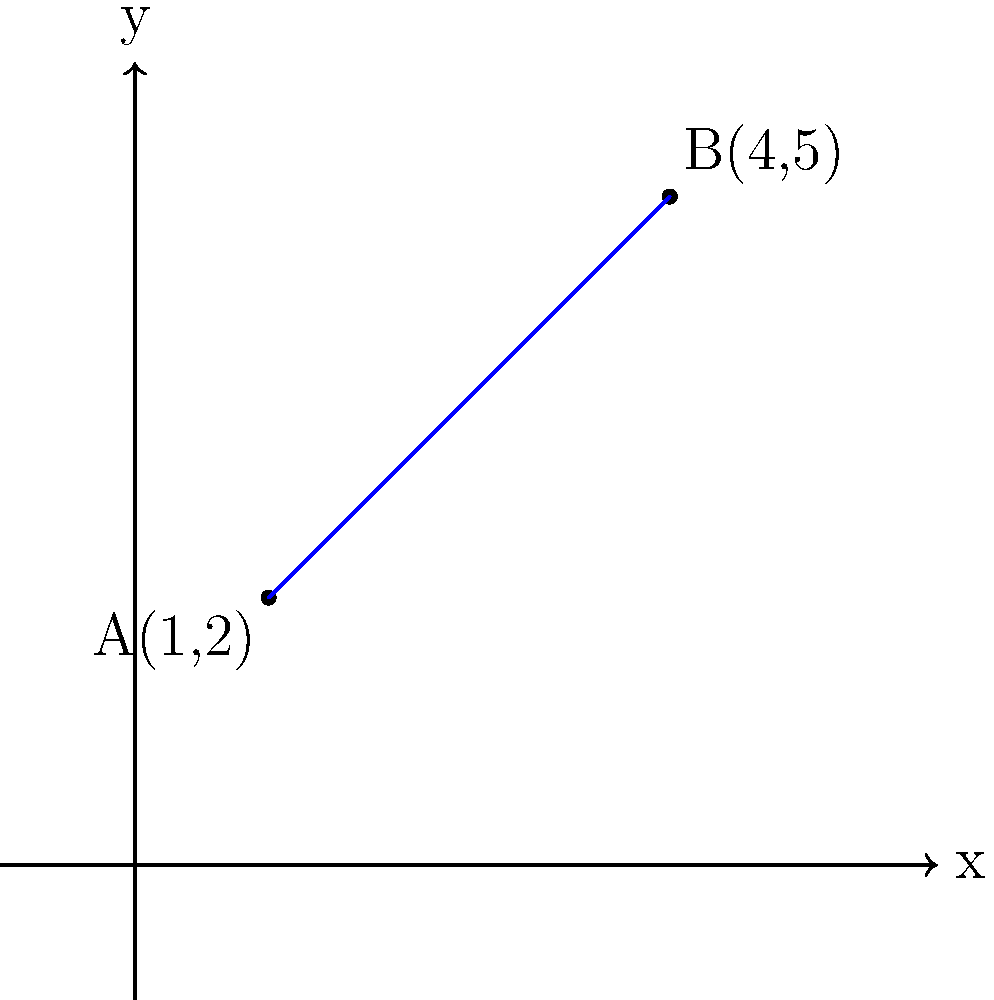As a Java developer, you're working on a geometry-based application. You need to implement a method that calculates the equation of a line passing through two given points. Given the points A(1,2) and B(4,5) as shown in the graph, determine the equation of the line in slope-intercept form $(y = mx + b)$. Round your answer to two decimal places if necessary. To find the equation of a line passing through two points, we can follow these steps:

1. Calculate the slope (m) using the slope formula:
   $$m = \frac{y_2 - y_1}{x_2 - x_1} = \frac{5 - 2}{4 - 1} = \frac{3}{3} = 1$$

2. Use the point-slope form of a line equation:
   $$y - y_1 = m(x - x_1)$$

3. Substitute the slope and one of the points (let's use A(1,2)) into the point-slope form:
   $$y - 2 = 1(x - 1)$$

4. Distribute the slope:
   $$y - 2 = x - 1$$

5. Add 2 to both sides to isolate y:
   $$y = x - 1 + 2$$

6. Simplify to get the slope-intercept form:
   $$y = x + 1$$

Therefore, the equation of the line in slope-intercept form is $y = x + 1$, where the slope (m) is 1 and the y-intercept (b) is 1.
Answer: $y = x + 1$ 